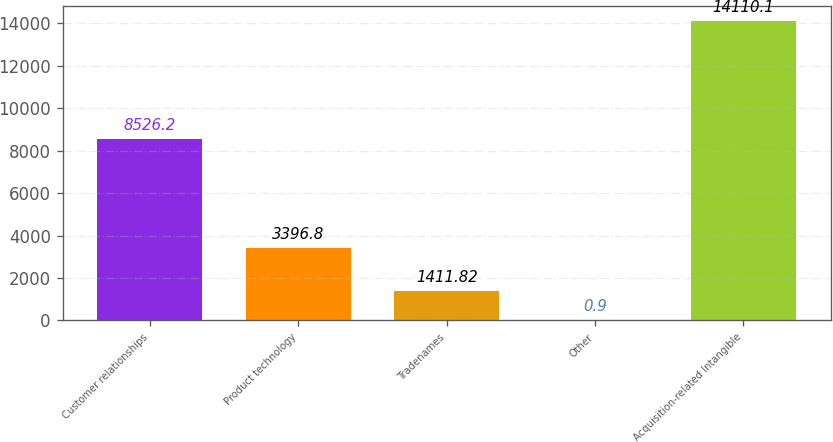Convert chart. <chart><loc_0><loc_0><loc_500><loc_500><bar_chart><fcel>Customer relationships<fcel>Product technology<fcel>Tradenames<fcel>Other<fcel>Acquisition-related Intangible<nl><fcel>8526.2<fcel>3396.8<fcel>1411.82<fcel>0.9<fcel>14110.1<nl></chart> 